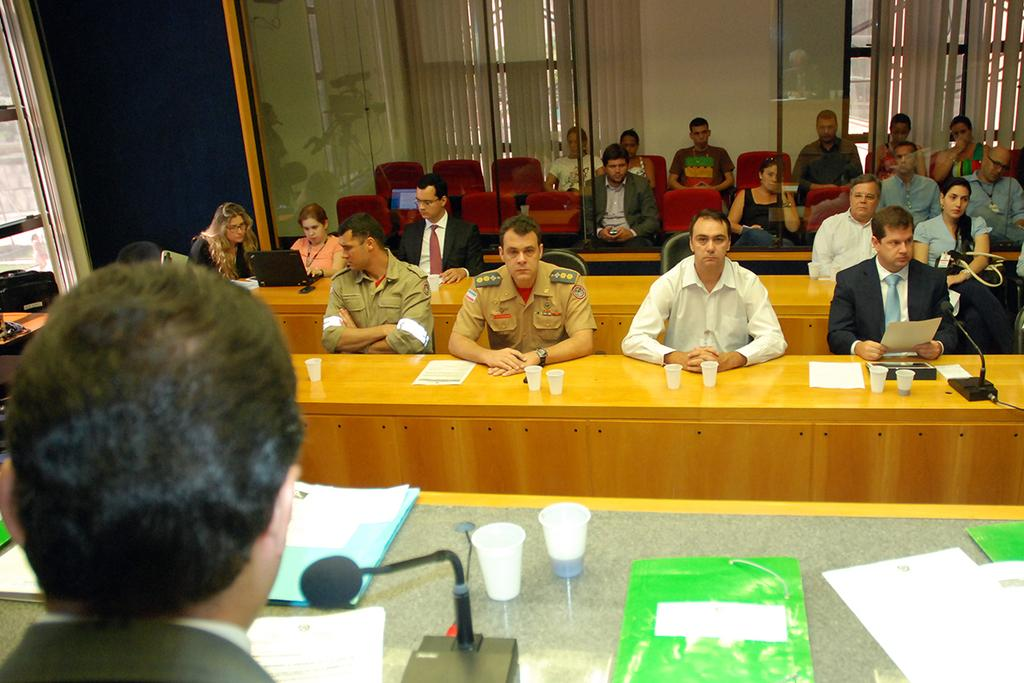How many people are in the image? There is a group of people in the image. What are the people doing in the image? The people are sitting on chairs. Where are the chairs located in relation to the table? The chairs are in front of a table. What can be found on the table in the image? There are cups and a microphone on the table, but where are the chickens in the image? What type of trouble might the people be discussing at the table? The image does not provide any information about the conversation or topic being discussed. Is there a truck visible in the image? There is no truck present in the image. 